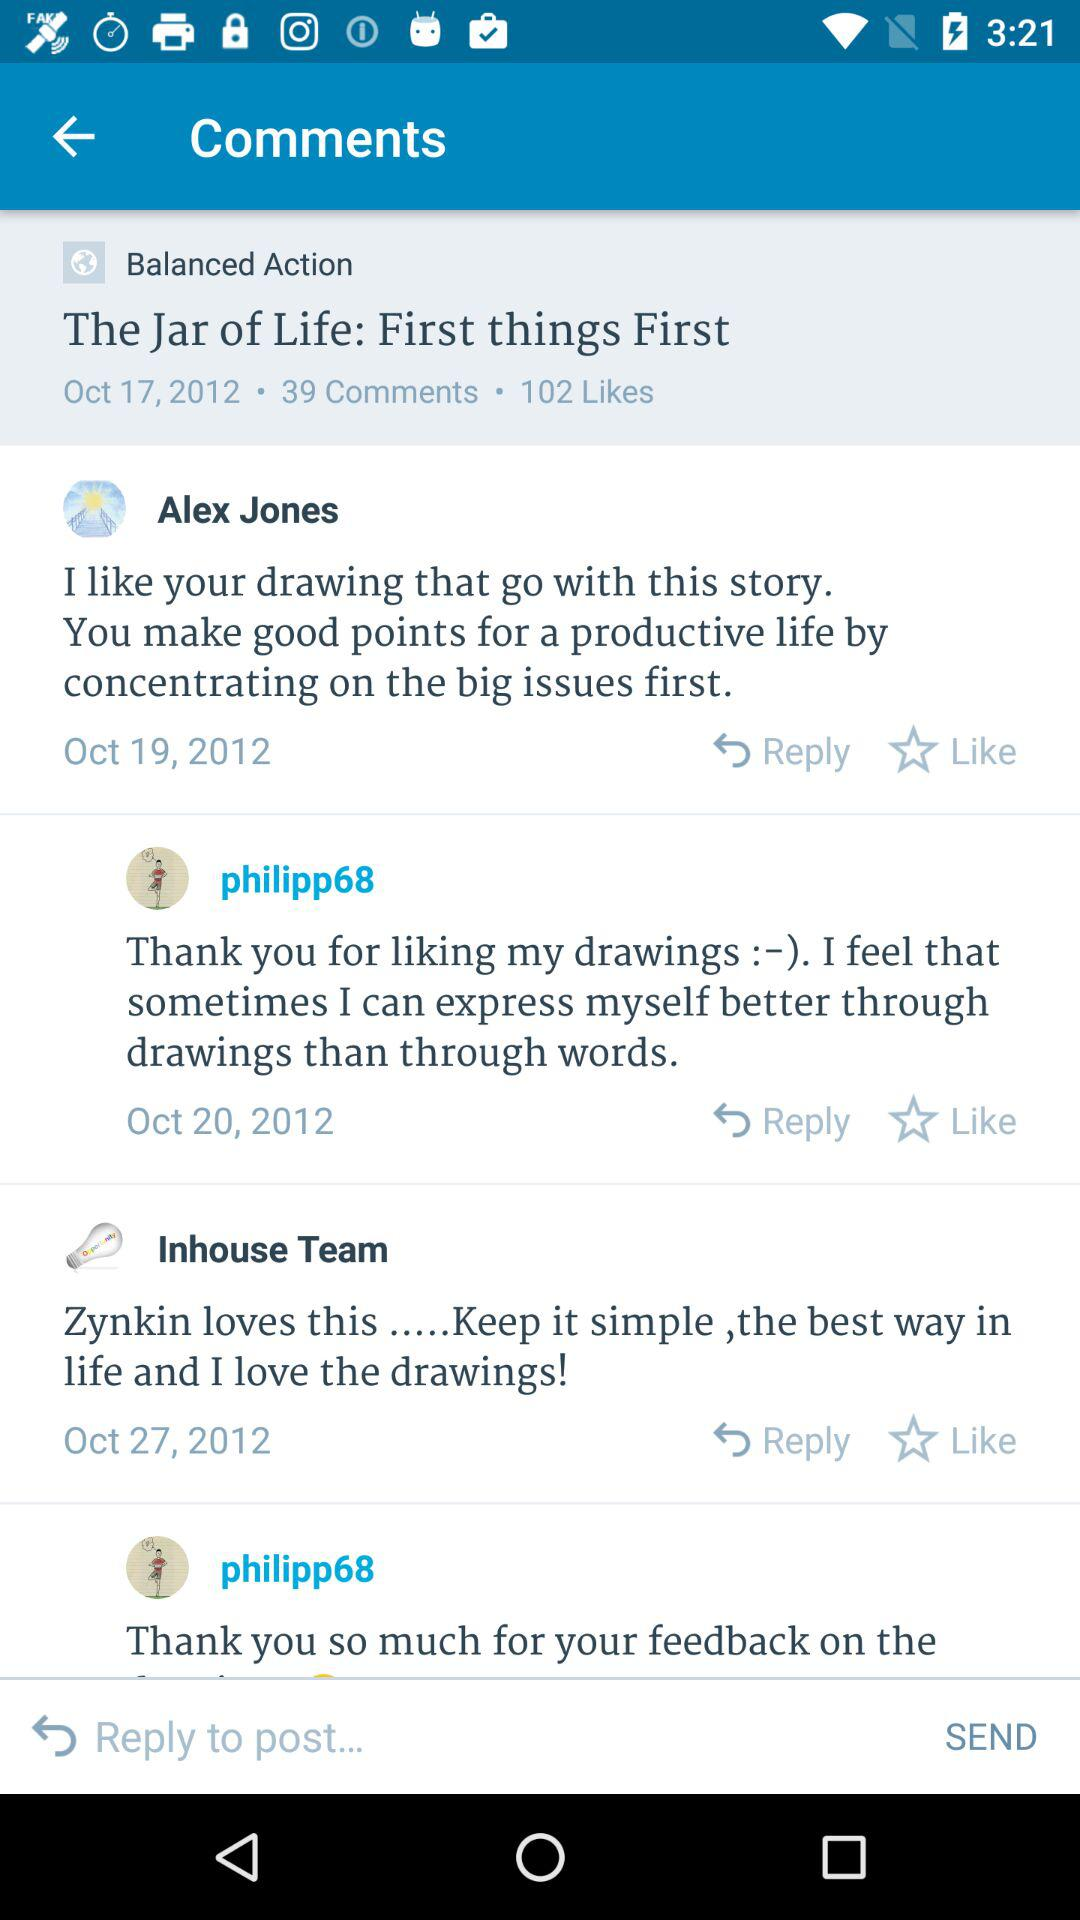How many likes does this post have?
Answer the question using a single word or phrase. 102 